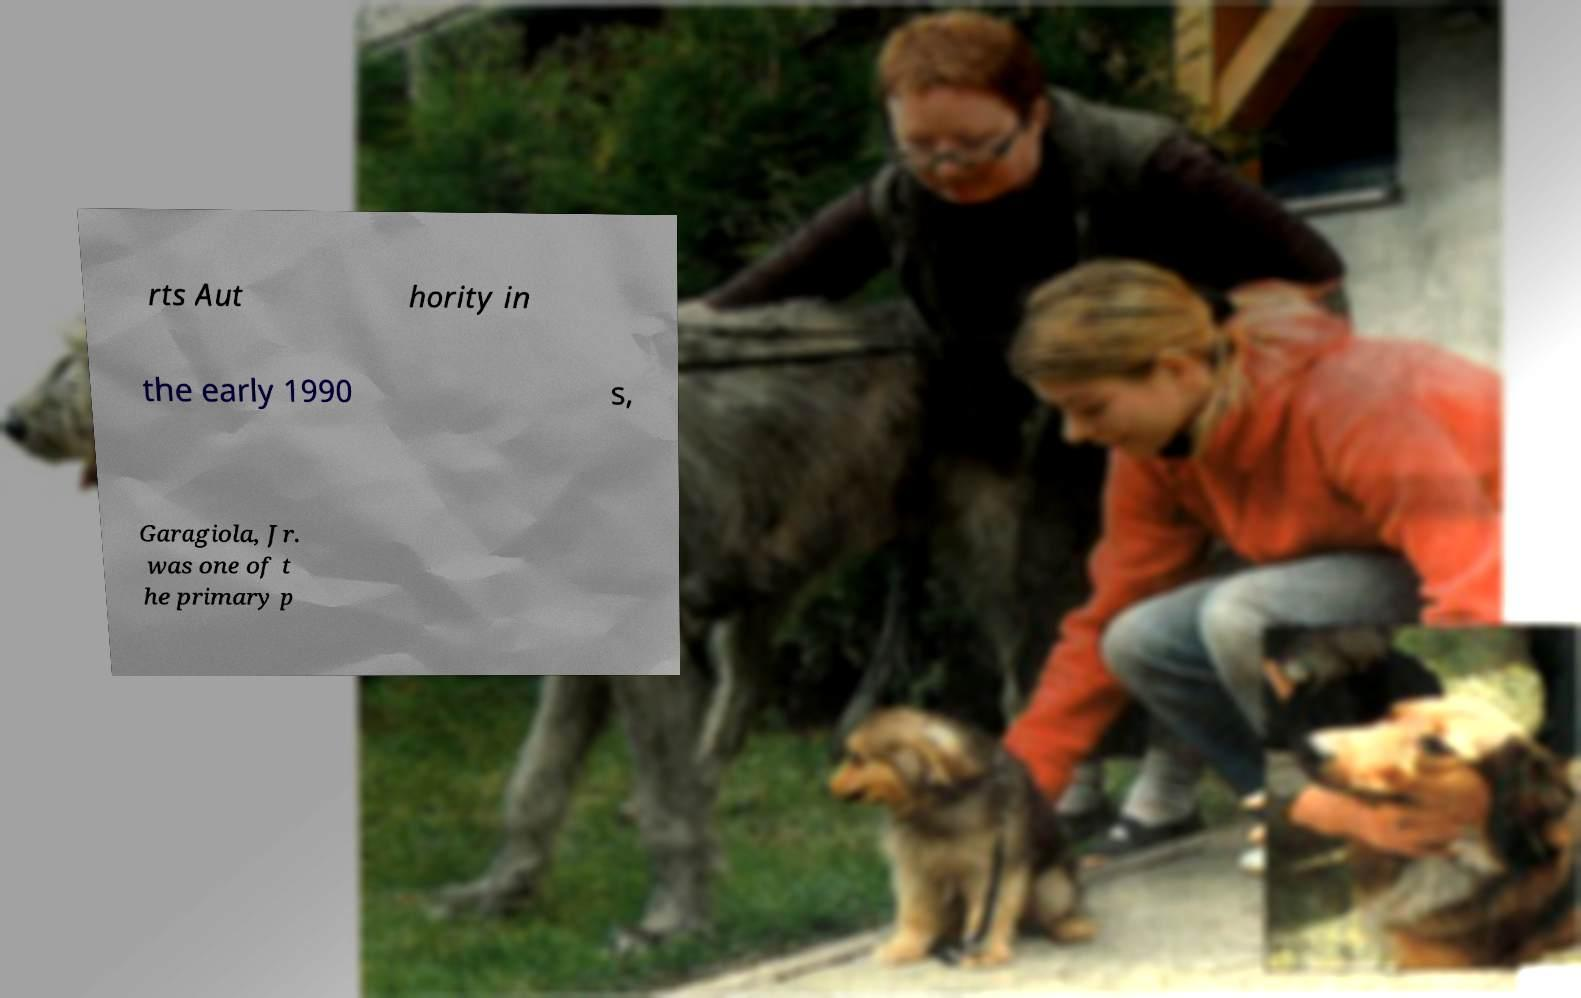Please identify and transcribe the text found in this image. rts Aut hority in the early 1990 s, Garagiola, Jr. was one of t he primary p 